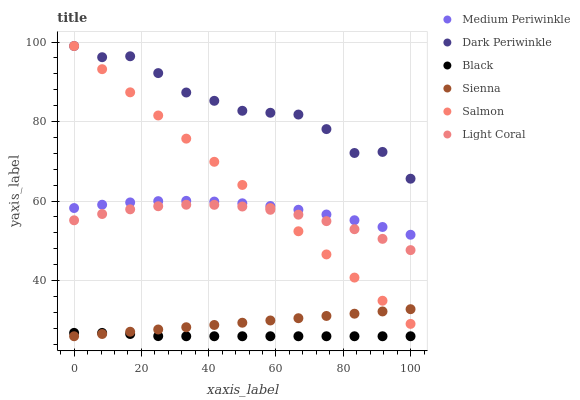Does Black have the minimum area under the curve?
Answer yes or no. Yes. Does Dark Periwinkle have the maximum area under the curve?
Answer yes or no. Yes. Does Salmon have the minimum area under the curve?
Answer yes or no. No. Does Salmon have the maximum area under the curve?
Answer yes or no. No. Is Sienna the smoothest?
Answer yes or no. Yes. Is Dark Periwinkle the roughest?
Answer yes or no. Yes. Is Salmon the smoothest?
Answer yes or no. No. Is Salmon the roughest?
Answer yes or no. No. Does Sienna have the lowest value?
Answer yes or no. Yes. Does Salmon have the lowest value?
Answer yes or no. No. Does Dark Periwinkle have the highest value?
Answer yes or no. Yes. Does Medium Periwinkle have the highest value?
Answer yes or no. No. Is Sienna less than Dark Periwinkle?
Answer yes or no. Yes. Is Dark Periwinkle greater than Medium Periwinkle?
Answer yes or no. Yes. Does Salmon intersect Light Coral?
Answer yes or no. Yes. Is Salmon less than Light Coral?
Answer yes or no. No. Is Salmon greater than Light Coral?
Answer yes or no. No. Does Sienna intersect Dark Periwinkle?
Answer yes or no. No. 